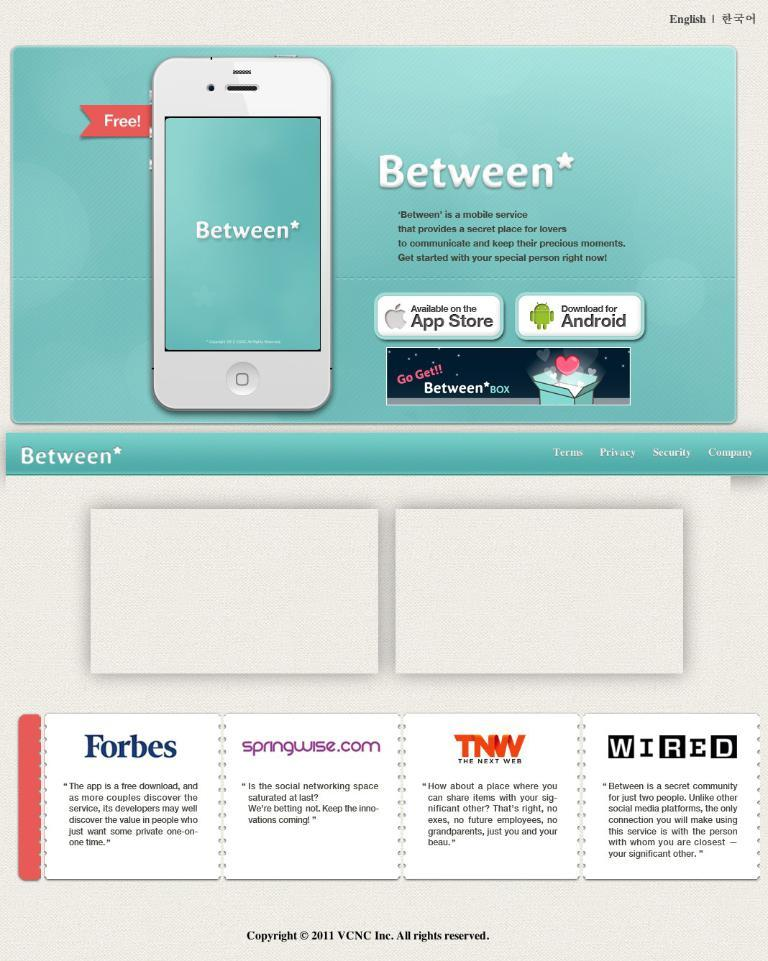<image>
Share a concise interpretation of the image provided. An Ad detailing the app Between with many sites giving good words at the bottom. 